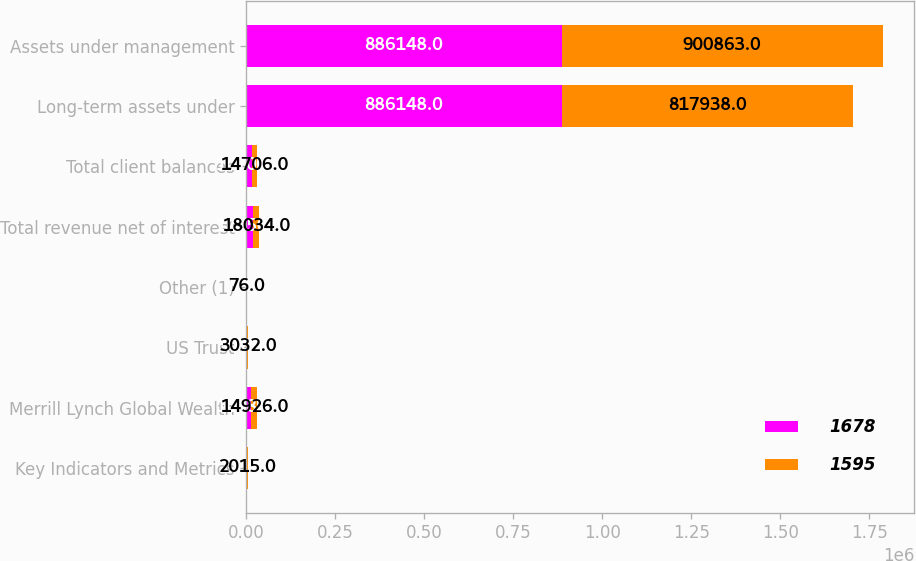<chart> <loc_0><loc_0><loc_500><loc_500><stacked_bar_chart><ecel><fcel>Key Indicators and Metrics<fcel>Merrill Lynch Global Wealth<fcel>US Trust<fcel>Other (1)<fcel>Total revenue net of interest<fcel>Total client balances<fcel>Long-term assets under<fcel>Assets under management<nl><fcel>1678<fcel>2016<fcel>14486<fcel>3075<fcel>89<fcel>17650<fcel>14706<fcel>886148<fcel>886148<nl><fcel>1595<fcel>2015<fcel>14926<fcel>3032<fcel>76<fcel>18034<fcel>14706<fcel>817938<fcel>900863<nl></chart> 